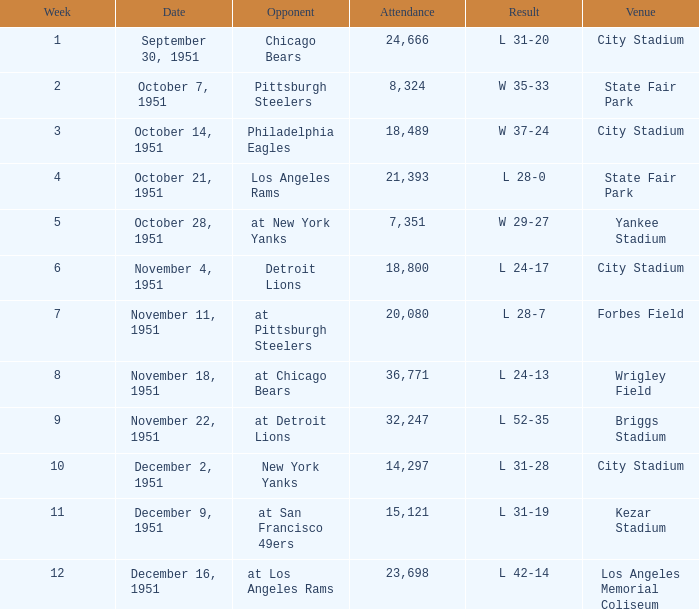Which venue hosted the Los Angeles Rams as an opponent? State Fair Park. 